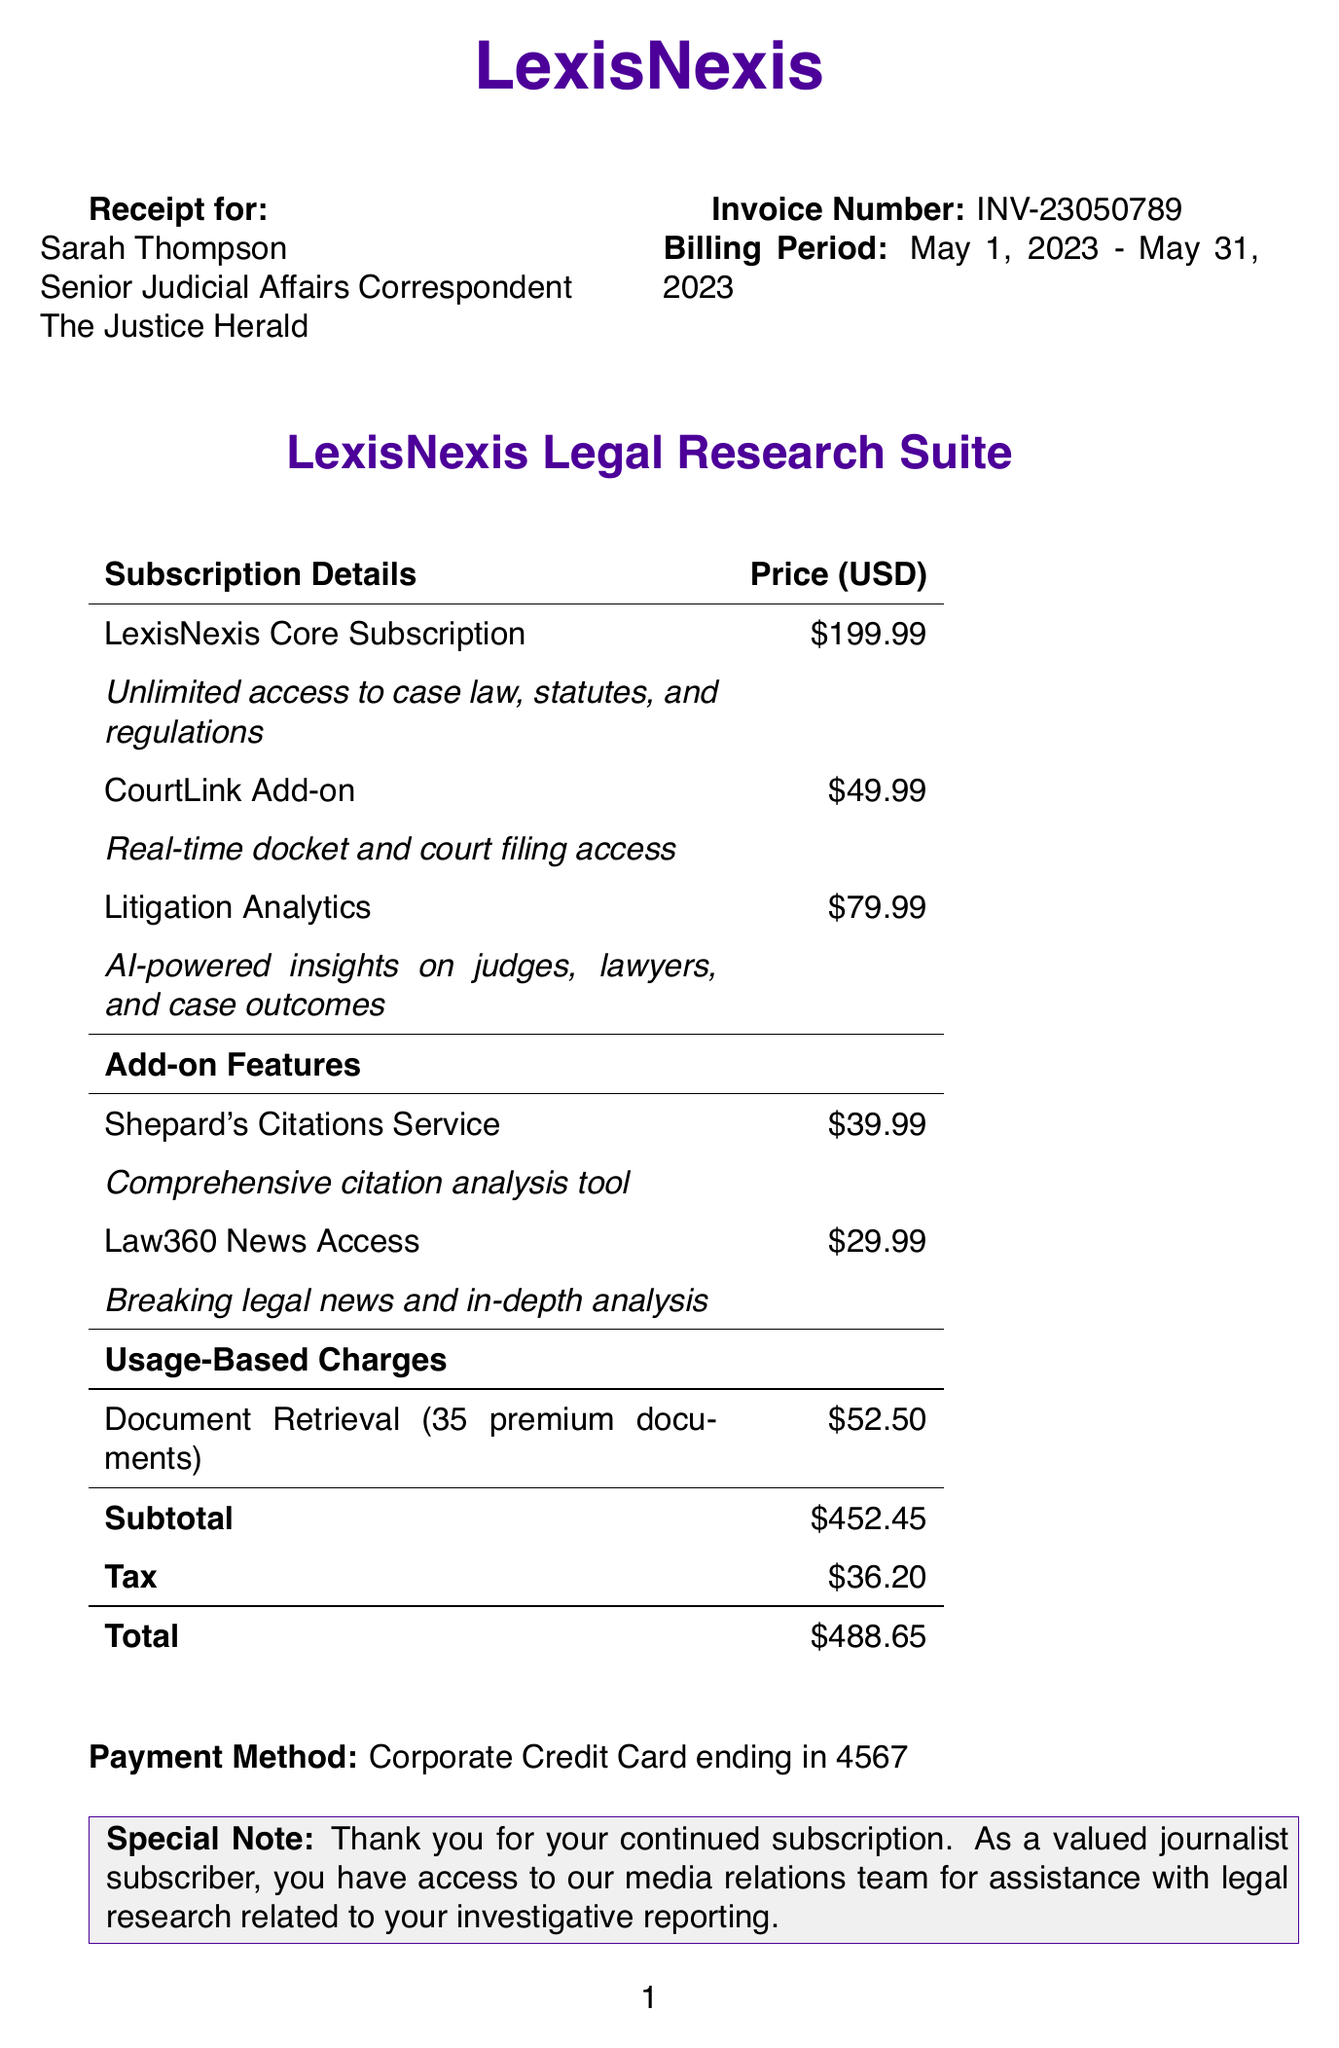What is the name of the company? The company name is stated at the top of the receipt.
Answer: LexisNexis What is the billing period covered by this receipt? The billing period is specifically mentioned below the customer information section.
Answer: May 1, 2023 - May 31, 2023 What is the total amount charged? The total amount is listed in bold at the bottom of the table called "Total".
Answer: $488.65 Who is the customer organization? The customer organization is mentioned right under the customer's title.
Answer: The Justice Herald What is the price of the Litigation Analytics feature? The price can be found under the Subscription Details section of the document.
Answer: $79.99 How many premium documents were accessed for the usage-based charge? The number of premium documents is specified in the description of the usage-based charges.
Answer: 35 What is the invoice number? The invoice number appears in bold near the top of the receipt.
Answer: INV-23050789 Which add-on feature costs $39.99? The price is associated with a specific add-on feature in the Add-on Features section.
Answer: Shepard's Citations Service Who is the account manager? The account manager's name is listed in the account manager section of the receipt.
Answer: Michael Chen 